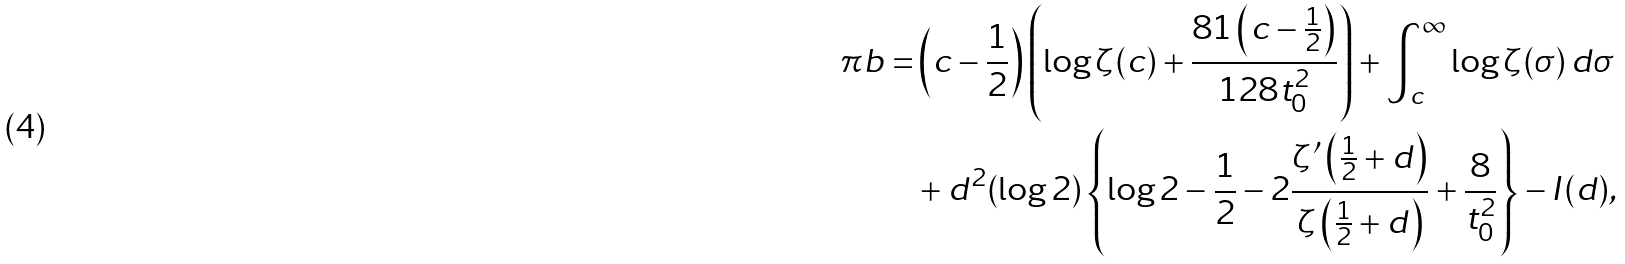Convert formula to latex. <formula><loc_0><loc_0><loc_500><loc_500>\pi b = & \left ( c - \frac { 1 } { 2 } \right ) \left ( \log \zeta ( c ) + \frac { 8 1 \left ( c - \frac { 1 } { 2 } \right ) } { 1 2 8 t _ { 0 } ^ { 2 } } \right ) + \int _ { c } ^ { \infty } \log \zeta ( \sigma ) \, d \sigma \\ & + d ^ { 2 } ( \log 2 ) \left \{ \log 2 - \frac { 1 } { 2 } - 2 \frac { \zeta ^ { \prime } \left ( \frac { 1 } { 2 } + d \right ) } { \zeta \left ( \frac { 1 } { 2 } + d \right ) } + \frac { 8 } { t _ { 0 } ^ { 2 } } \right \} - I ( d ) ,</formula> 